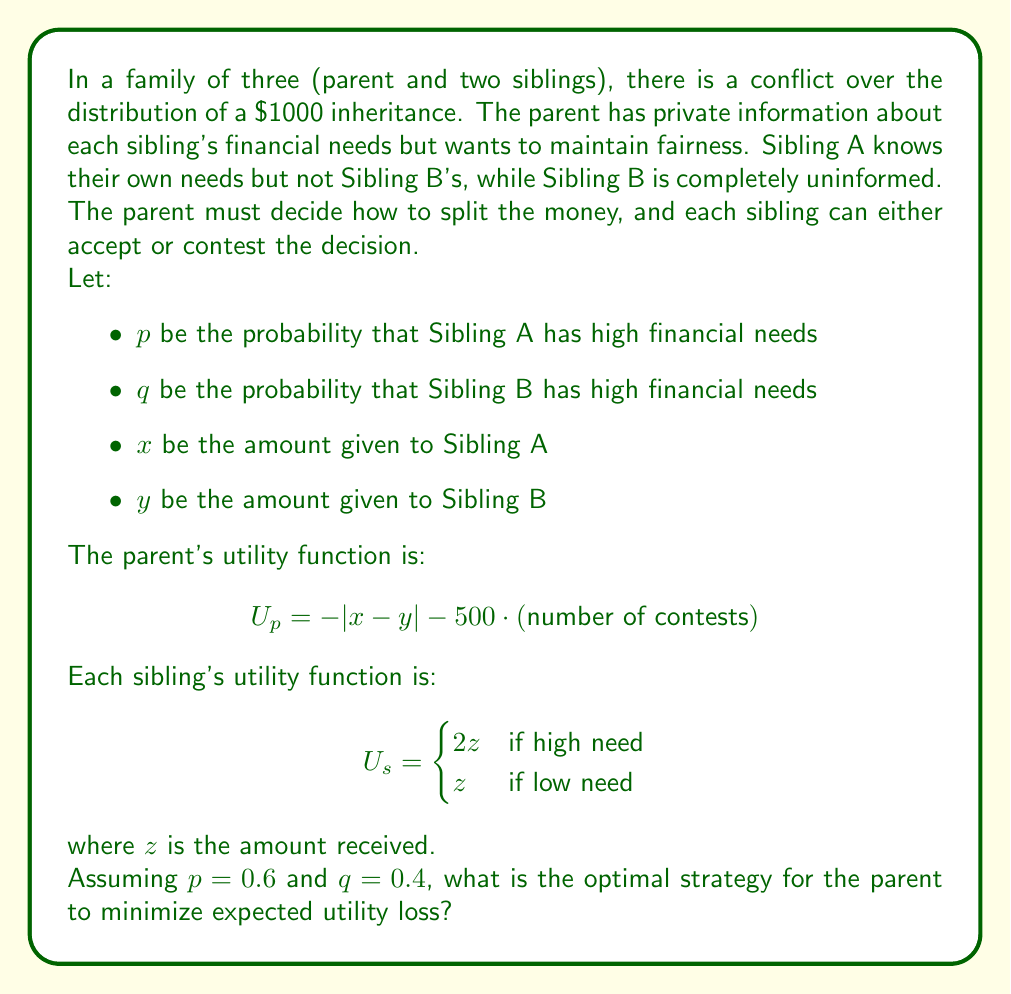Solve this math problem. To solve this Bayesian game, we need to consider the information asymmetry and potential outcomes:

1. First, let's analyze the possible scenarios:
   - Both siblings have high needs: probability $(0.6)(0.4) = 0.24$
   - Only Sibling A has high needs: probability $(0.6)(0.6) = 0.36$
   - Only Sibling B has high needs: probability $(0.4)(0.4) = 0.16$
   - Neither sibling has high needs: probability $(0.4)(0.6) = 0.24$

2. The parent's strategy should aim to minimize contests while maintaining fairness. Let's consider a strategy where the parent offers:
   - $(x, y) = (600, 400)$ if they believe Sibling A has high needs
   - $(x, y) = (400, 600)$ if they believe Sibling B has high needs
   - $(x, y) = (500, 500)$ if they believe needs are equal

3. Now, let's calculate the expected utility for each sibling:
   - For Sibling A (high need): $E[U_A] = 0.6(2(600)) + 0.4(2(400)) = 1040$
   - For Sibling A (low need): $E[U_A] = 0.6(600) + 0.4(400) = 520$
   - For Sibling B (high need): $E[U_B] = 0.4(2(600)) + 0.6(2(400)) = 960$
   - For Sibling B (low need): $E[U_B] = 0.4(600) + 0.6(400) = 480$

4. Given these expected utilities, neither sibling has an incentive to contest if they receive their expected amount or higher.

5. The parent's expected utility loss:
   $$E[U_p] = -0.24(200) - 0.36(200) - 0.16(200) - 0.24(0) = -152$$

6. This strategy minimizes the expected number of contests (likely zero) while maintaining a degree of fairness based on the probabilities of each sibling's needs.

7. Alternative strategies, such as always splitting equally or giving more to the sibling with the higher probability of need, would result in a higher expected utility loss for the parent due to increased likelihood of contests or larger disparities in allocation.
Answer: The optimal strategy for the parent to minimize expected utility loss is:
- Offer $(x, y) = (600, 400)$ with probability 0.6
- Offer $(x, y) = (400, 600)$ with probability 0.4

This strategy results in an expected utility loss of -152 for the parent and minimizes the likelihood of contests from either sibling. 